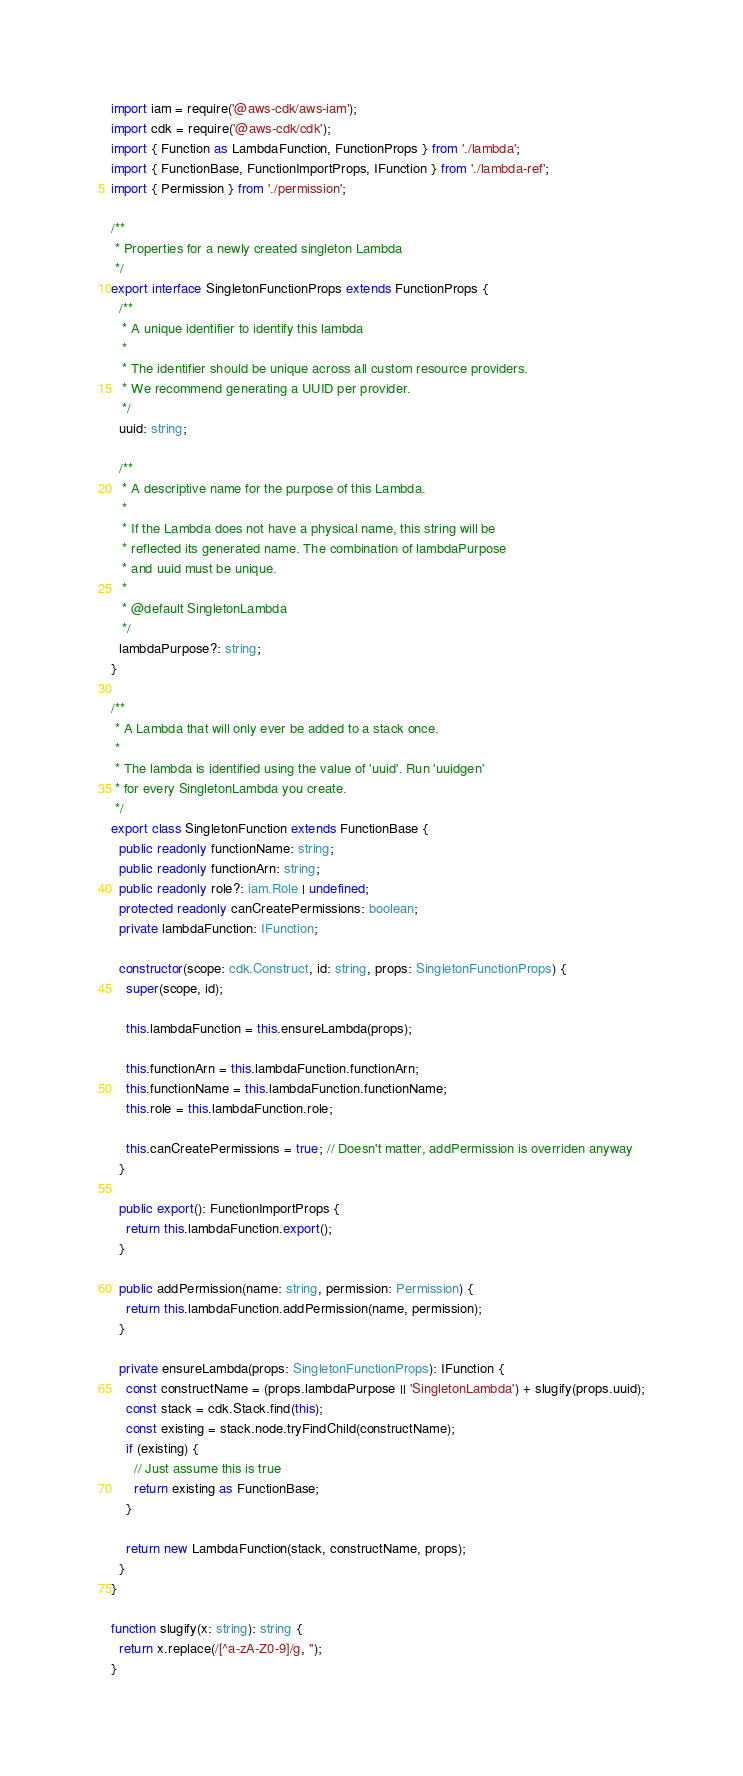Convert code to text. <code><loc_0><loc_0><loc_500><loc_500><_TypeScript_>import iam = require('@aws-cdk/aws-iam');
import cdk = require('@aws-cdk/cdk');
import { Function as LambdaFunction, FunctionProps } from './lambda';
import { FunctionBase, FunctionImportProps, IFunction } from './lambda-ref';
import { Permission } from './permission';

/**
 * Properties for a newly created singleton Lambda
 */
export interface SingletonFunctionProps extends FunctionProps {
  /**
   * A unique identifier to identify this lambda
   *
   * The identifier should be unique across all custom resource providers.
   * We recommend generating a UUID per provider.
   */
  uuid: string;

  /**
   * A descriptive name for the purpose of this Lambda.
   *
   * If the Lambda does not have a physical name, this string will be
   * reflected its generated name. The combination of lambdaPurpose
   * and uuid must be unique.
   *
   * @default SingletonLambda
   */
  lambdaPurpose?: string;
}

/**
 * A Lambda that will only ever be added to a stack once.
 *
 * The lambda is identified using the value of 'uuid'. Run 'uuidgen'
 * for every SingletonLambda you create.
 */
export class SingletonFunction extends FunctionBase {
  public readonly functionName: string;
  public readonly functionArn: string;
  public readonly role?: iam.Role | undefined;
  protected readonly canCreatePermissions: boolean;
  private lambdaFunction: IFunction;

  constructor(scope: cdk.Construct, id: string, props: SingletonFunctionProps) {
    super(scope, id);

    this.lambdaFunction = this.ensureLambda(props);

    this.functionArn = this.lambdaFunction.functionArn;
    this.functionName = this.lambdaFunction.functionName;
    this.role = this.lambdaFunction.role;

    this.canCreatePermissions = true; // Doesn't matter, addPermission is overriden anyway
  }

  public export(): FunctionImportProps {
    return this.lambdaFunction.export();
  }

  public addPermission(name: string, permission: Permission) {
    return this.lambdaFunction.addPermission(name, permission);
  }

  private ensureLambda(props: SingletonFunctionProps): IFunction {
    const constructName = (props.lambdaPurpose || 'SingletonLambda') + slugify(props.uuid);
    const stack = cdk.Stack.find(this);
    const existing = stack.node.tryFindChild(constructName);
    if (existing) {
      // Just assume this is true
      return existing as FunctionBase;
    }

    return new LambdaFunction(stack, constructName, props);
  }
}

function slugify(x: string): string {
  return x.replace(/[^a-zA-Z0-9]/g, '');
}
</code> 